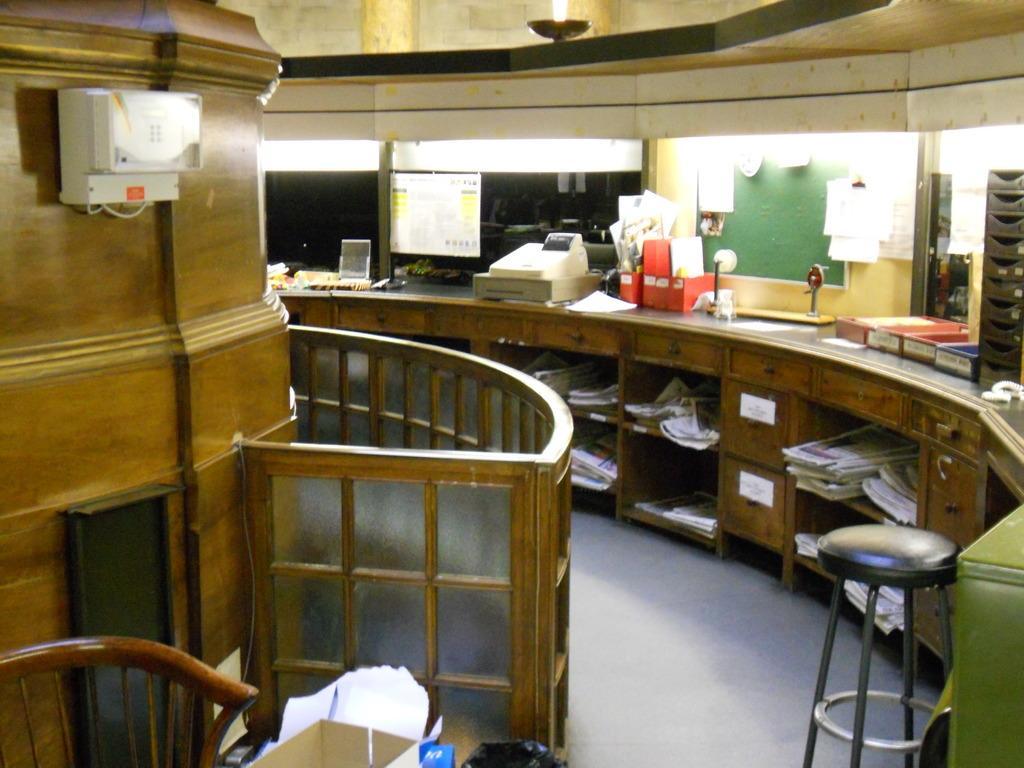Could you give a brief overview of what you see in this image? This picture is taken inside the room. In this image, on the left side, we can see an electronic machine attached to a wall, glass door. On the left side, we can see a table, on that table, we can see some books, electronic instrument, papers, we can also see another table on the right side. At the top, we can see a roof, at the bottom, we can see some boxes, polythene cover and papers. 